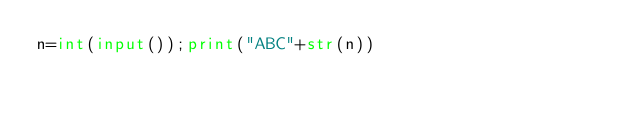Convert code to text. <code><loc_0><loc_0><loc_500><loc_500><_Python_>n=int(input());print("ABC"+str(n))</code> 